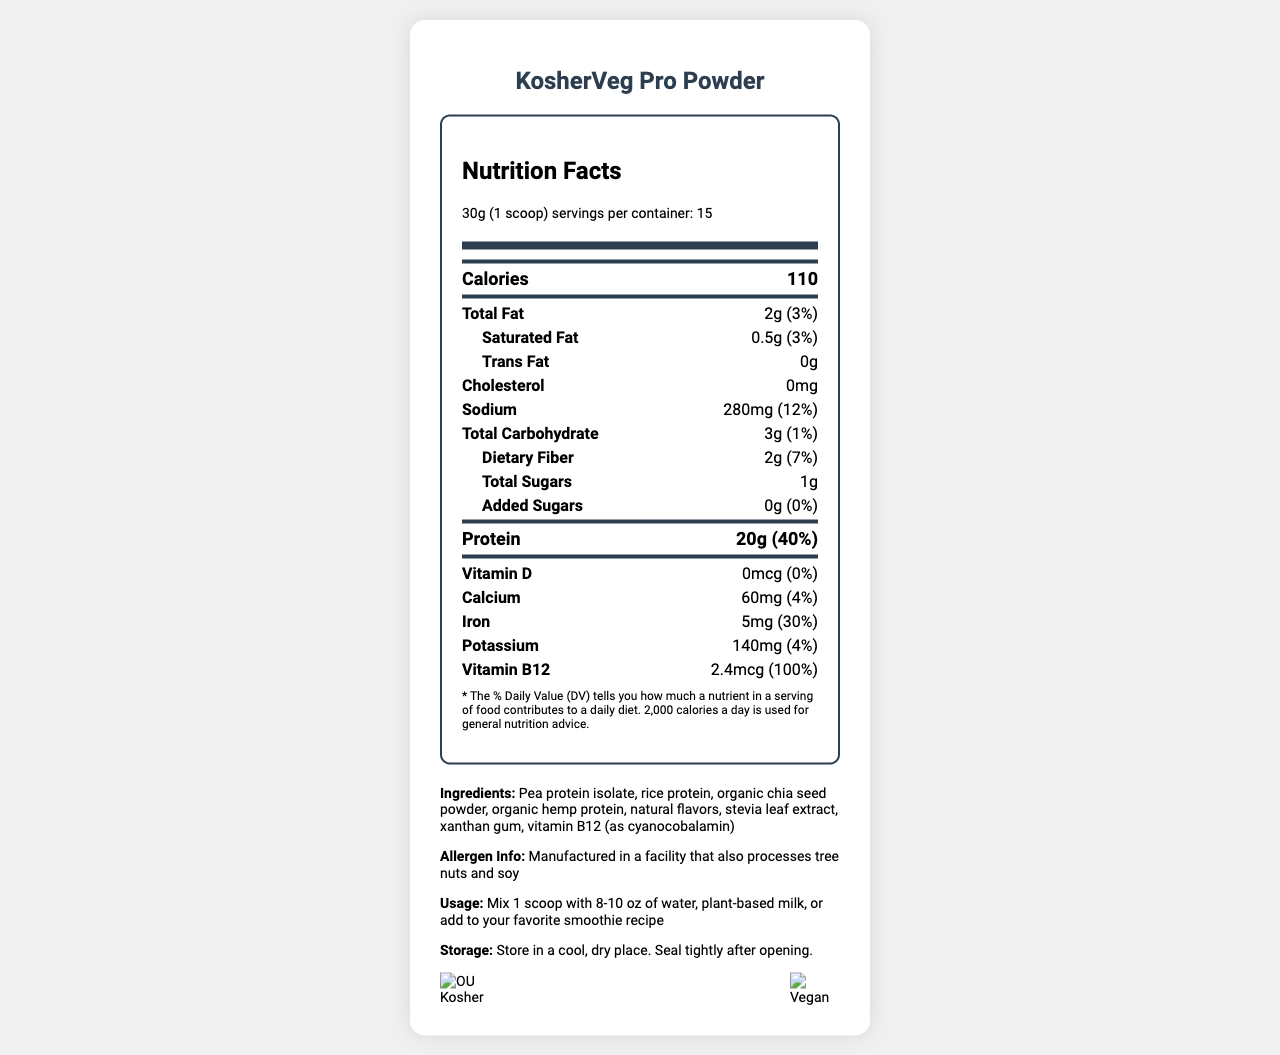what is the serving size? The serving size is clearly listed as "30g (1 scoop)" in the document.
Answer: 30g (1 scoop) how many servings are in one container? The document states that there are 15 servings per container.
Answer: 15 how much protein is in one serving? The protein content per serving listed is 20g.
Answer: 20g what is the sodium content in one serving? The sodium content for each serving is specified as 280mg.
Answer: 280mg what is the daily value percentage of iron? The document lists the daily value percentage of iron as 30%.
Answer: 30% which vitamin has a daily value of 100%? A. Vitamin D B. Vitamin C C. Vitamin B12 D. Vitamin A The document indicates that the vitamin B12 amount is 2.4mcg with a daily value of 100%.
Answer: C. Vitamin B12 what is the total carbohydrate content per serving? A. 2g B. 3g C. 5g D. 4g The total carbohydrate content per serving is listed as 3g.
Answer: B. 3g is the protein powder vegan? The document states that the product is "100% Vegan" in the additional information section.
Answer: Yes how should the product be stored? The document provides clear storage instructions: "Store in a cool, dry place. Seal tightly after opening."
Answer: Store in a cool, dry place. Seal tightly after opening. does the product contain any added sugars? The document indicates that the amount of added sugars is 0g with a daily value of 0%.
Answer: No summarize the main details about the KosherVeg Pro Powder This summary includes the product's main attributes, nutritional information, certifications, and instructions for use and storage.
Answer: The KosherVeg Pro Powder is a plant-based protein powder with 20g of protein per serving and fortified with vitamin B12. It is kosher-certified, vegan, non-GMO, and gluten-free. Each serving size is 30g, with 15 servings per container. It contains 110 calories, 2g of total fat, 280mg of sodium, 3g of carbohydrates, and 2g of dietary fiber. The product should be stored in a cool, dry place and sealed tightly after opening. what is the certification of the product? The document states that the product is certified as "OU Kosher Pareve."
Answer: OU Kosher Pareve is there any cholesterol in the product? The document lists the cholesterol content as 0mg, indicating that the product contains no cholesterol.
Answer: No who is the manufacturer of the product? The document does not provide any details about the manufacturer, so the information cannot be determined from the visual data provided.
Answer: Not enough information 